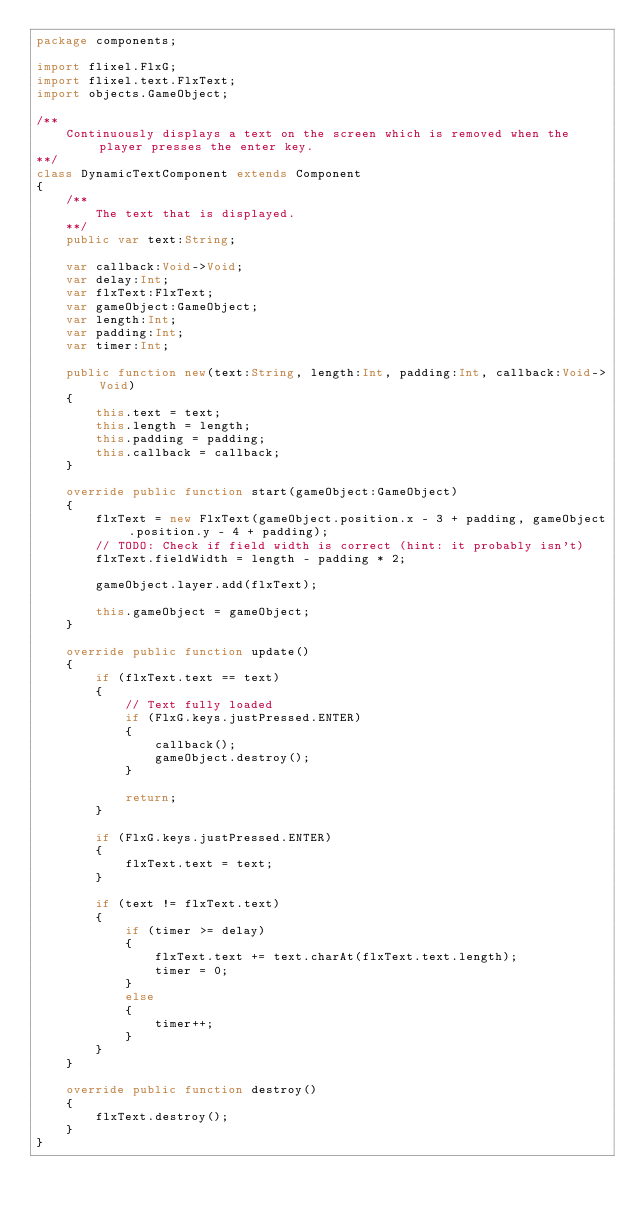Convert code to text. <code><loc_0><loc_0><loc_500><loc_500><_Haxe_>package components;

import flixel.FlxG;
import flixel.text.FlxText;
import objects.GameObject;

/**
    Continuously displays a text on the screen which is removed when the player presses the enter key.
**/
class DynamicTextComponent extends Component
{
    /**
        The text that is displayed.
    **/
    public var text:String;

    var callback:Void->Void;
    var delay:Int;
    var flxText:FlxText;
    var gameObject:GameObject;
    var length:Int;
    var padding:Int;
    var timer:Int;

    public function new(text:String, length:Int, padding:Int, callback:Void->Void)
    {
        this.text = text;
        this.length = length;
        this.padding = padding;
        this.callback = callback;
    }

    override public function start(gameObject:GameObject)
    {
        flxText = new FlxText(gameObject.position.x - 3 + padding, gameObject.position.y - 4 + padding);
        // TODO: Check if field width is correct (hint: it probably isn't)
        flxText.fieldWidth = length - padding * 2;

        gameObject.layer.add(flxText);

        this.gameObject = gameObject;
    }

    override public function update()
    {
        if (flxText.text == text)
        {
            // Text fully loaded
            if (FlxG.keys.justPressed.ENTER)
            {
                callback();
                gameObject.destroy();
            }

            return;
        }

        if (FlxG.keys.justPressed.ENTER)
        {
            flxText.text = text;
        }

        if (text != flxText.text)
        {
            if (timer >= delay)
            {
                flxText.text += text.charAt(flxText.text.length);
                timer = 0;
            }
            else
            {
                timer++;
            }
        }
    }

    override public function destroy()
    {
        flxText.destroy();
    }
}</code> 